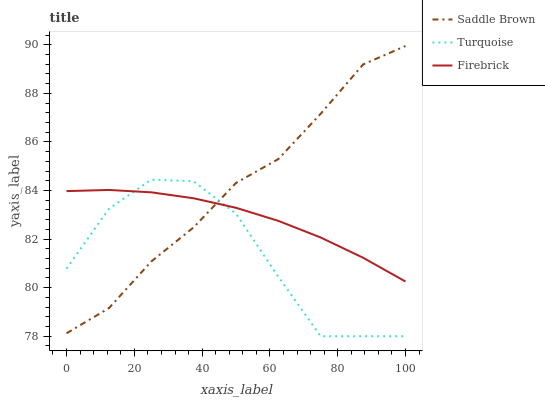Does Turquoise have the minimum area under the curve?
Answer yes or no. Yes. Does Saddle Brown have the maximum area under the curve?
Answer yes or no. Yes. Does Saddle Brown have the minimum area under the curve?
Answer yes or no. No. Does Turquoise have the maximum area under the curve?
Answer yes or no. No. Is Firebrick the smoothest?
Answer yes or no. Yes. Is Turquoise the roughest?
Answer yes or no. Yes. Is Saddle Brown the smoothest?
Answer yes or no. No. Is Saddle Brown the roughest?
Answer yes or no. No. Does Turquoise have the lowest value?
Answer yes or no. Yes. Does Saddle Brown have the lowest value?
Answer yes or no. No. Does Saddle Brown have the highest value?
Answer yes or no. Yes. Does Turquoise have the highest value?
Answer yes or no. No. Does Saddle Brown intersect Turquoise?
Answer yes or no. Yes. Is Saddle Brown less than Turquoise?
Answer yes or no. No. Is Saddle Brown greater than Turquoise?
Answer yes or no. No. 